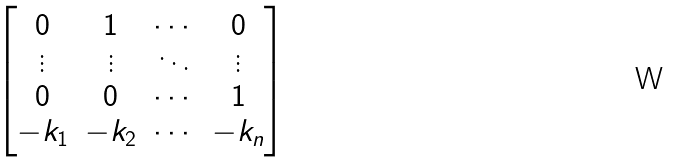Convert formula to latex. <formula><loc_0><loc_0><loc_500><loc_500>\begin{bmatrix} 0 & 1 & \cdots & 0 \\ \vdots & \vdots & \ddots & \vdots \\ 0 & 0 & \cdots & 1 \\ - k _ { 1 } & - k _ { 2 } & \cdots & - k _ { n } \end{bmatrix}</formula> 